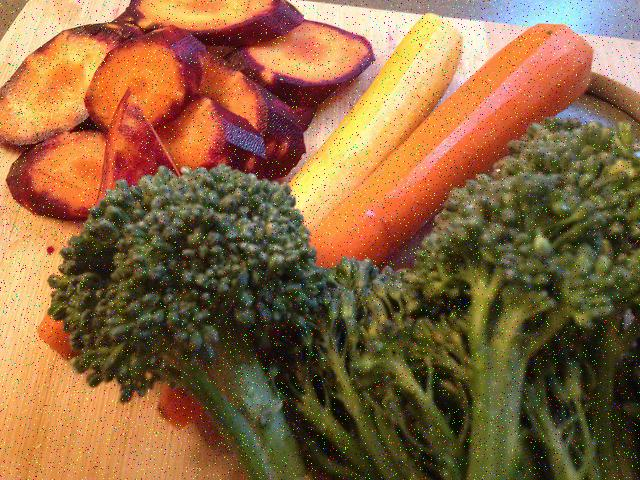What types of vegetables are shown in this image? The image displays a variety of vegetables including sliced purple-skinned ones likely to be sweet potatoes, whole carrots with a gradient of colors from yellow to orange, and a serving of green broccoli. It's a colorful assortment suggestive of healthful eating habits. 